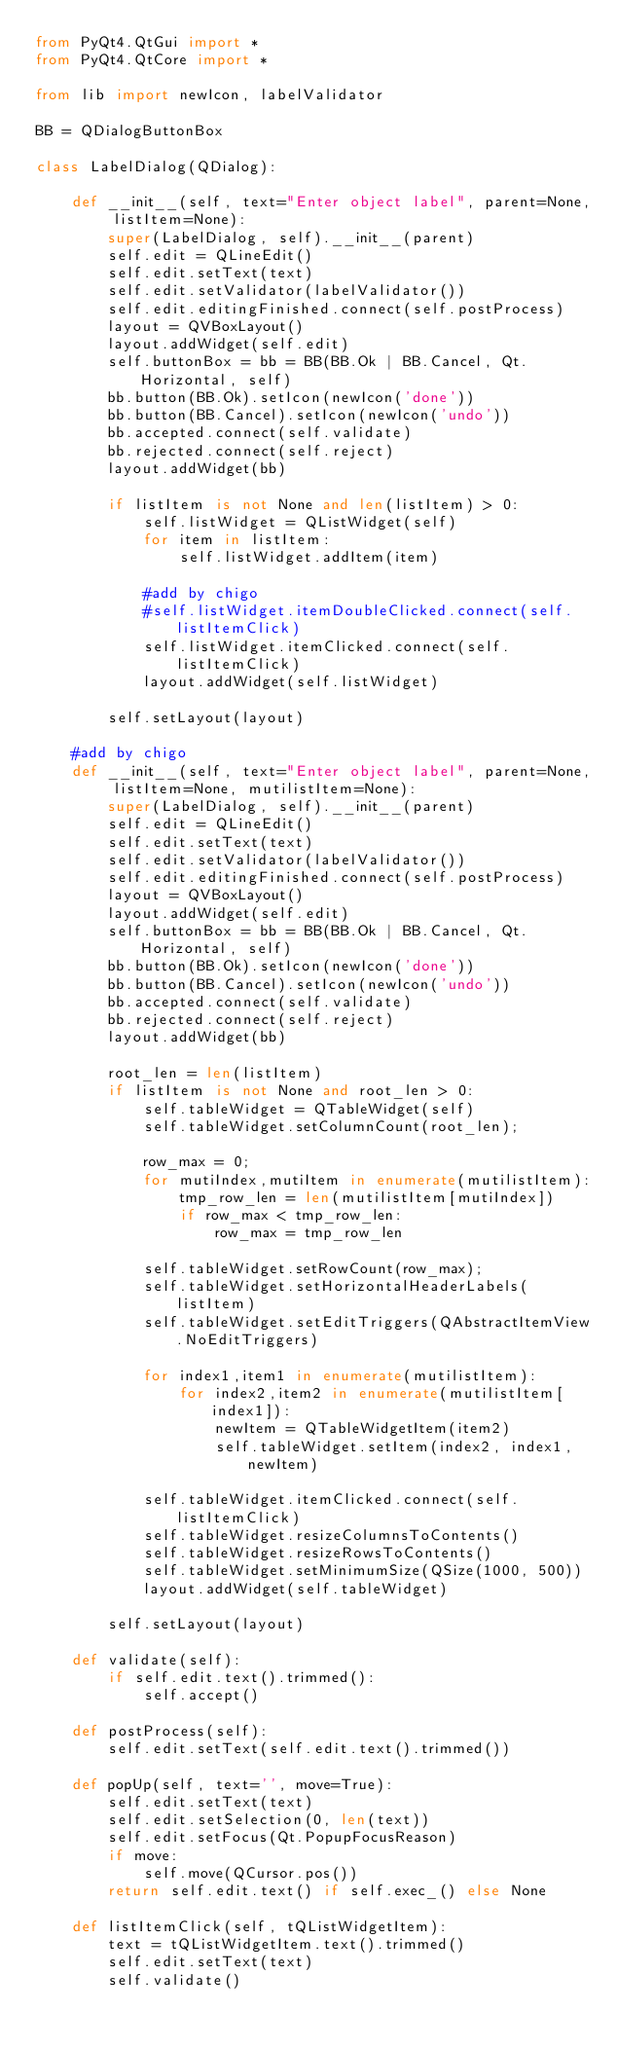Convert code to text. <code><loc_0><loc_0><loc_500><loc_500><_Python_>from PyQt4.QtGui import *
from PyQt4.QtCore import *

from lib import newIcon, labelValidator

BB = QDialogButtonBox

class LabelDialog(QDialog):

    def __init__(self, text="Enter object label", parent=None, listItem=None):
        super(LabelDialog, self).__init__(parent)
        self.edit = QLineEdit()
        self.edit.setText(text)
        self.edit.setValidator(labelValidator())
        self.edit.editingFinished.connect(self.postProcess)
        layout = QVBoxLayout()
        layout.addWidget(self.edit)
        self.buttonBox = bb = BB(BB.Ok | BB.Cancel, Qt.Horizontal, self)
        bb.button(BB.Ok).setIcon(newIcon('done'))
        bb.button(BB.Cancel).setIcon(newIcon('undo'))
        bb.accepted.connect(self.validate)
        bb.rejected.connect(self.reject)
        layout.addWidget(bb)

        if listItem is not None and len(listItem) > 0:
            self.listWidget = QListWidget(self)
            for item in listItem:
                self.listWidget.addItem(item)

            #add by chigo
            #self.listWidget.itemDoubleClicked.connect(self.listItemClick)
            self.listWidget.itemClicked.connect(self.listItemClick)
            layout.addWidget(self.listWidget)

        self.setLayout(layout)

    #add by chigo
    def __init__(self, text="Enter object label", parent=None, listItem=None, mutilistItem=None):
        super(LabelDialog, self).__init__(parent)
        self.edit = QLineEdit()
        self.edit.setText(text)
        self.edit.setValidator(labelValidator())
        self.edit.editingFinished.connect(self.postProcess)
        layout = QVBoxLayout()
        layout.addWidget(self.edit)
        self.buttonBox = bb = BB(BB.Ok | BB.Cancel, Qt.Horizontal, self)
        bb.button(BB.Ok).setIcon(newIcon('done'))
        bb.button(BB.Cancel).setIcon(newIcon('undo'))
        bb.accepted.connect(self.validate)
        bb.rejected.connect(self.reject)
        layout.addWidget(bb)

        root_len = len(listItem)
        if listItem is not None and root_len > 0:
            self.tableWidget = QTableWidget(self)
            self.tableWidget.setColumnCount(root_len);

            row_max = 0;
            for mutiIndex,mutiItem in enumerate(mutilistItem):
                tmp_row_len = len(mutilistItem[mutiIndex])
                if row_max < tmp_row_len:
                    row_max = tmp_row_len

            self.tableWidget.setRowCount(row_max);
            self.tableWidget.setHorizontalHeaderLabels(listItem)
            self.tableWidget.setEditTriggers(QAbstractItemView.NoEditTriggers) 
            
            for index1,item1 in enumerate(mutilistItem):
                for index2,item2 in enumerate(mutilistItem[index1]):
                    newItem = QTableWidgetItem(item2)
                    self.tableWidget.setItem(index2, index1, newItem)

            self.tableWidget.itemClicked.connect(self.listItemClick)
            self.tableWidget.resizeColumnsToContents() 
            self.tableWidget.resizeRowsToContents() 
            self.tableWidget.setMinimumSize(QSize(1000, 500))
            layout.addWidget(self.tableWidget)  
            
        self.setLayout(layout)

    def validate(self):
        if self.edit.text().trimmed():
            self.accept()

    def postProcess(self):
        self.edit.setText(self.edit.text().trimmed())

    def popUp(self, text='', move=True):
        self.edit.setText(text)
        self.edit.setSelection(0, len(text))
        self.edit.setFocus(Qt.PopupFocusReason)
        if move:
            self.move(QCursor.pos())
        return self.edit.text() if self.exec_() else None

    def listItemClick(self, tQListWidgetItem):
        text = tQListWidgetItem.text().trimmed()
        self.edit.setText(text)
        self.validate()

</code> 